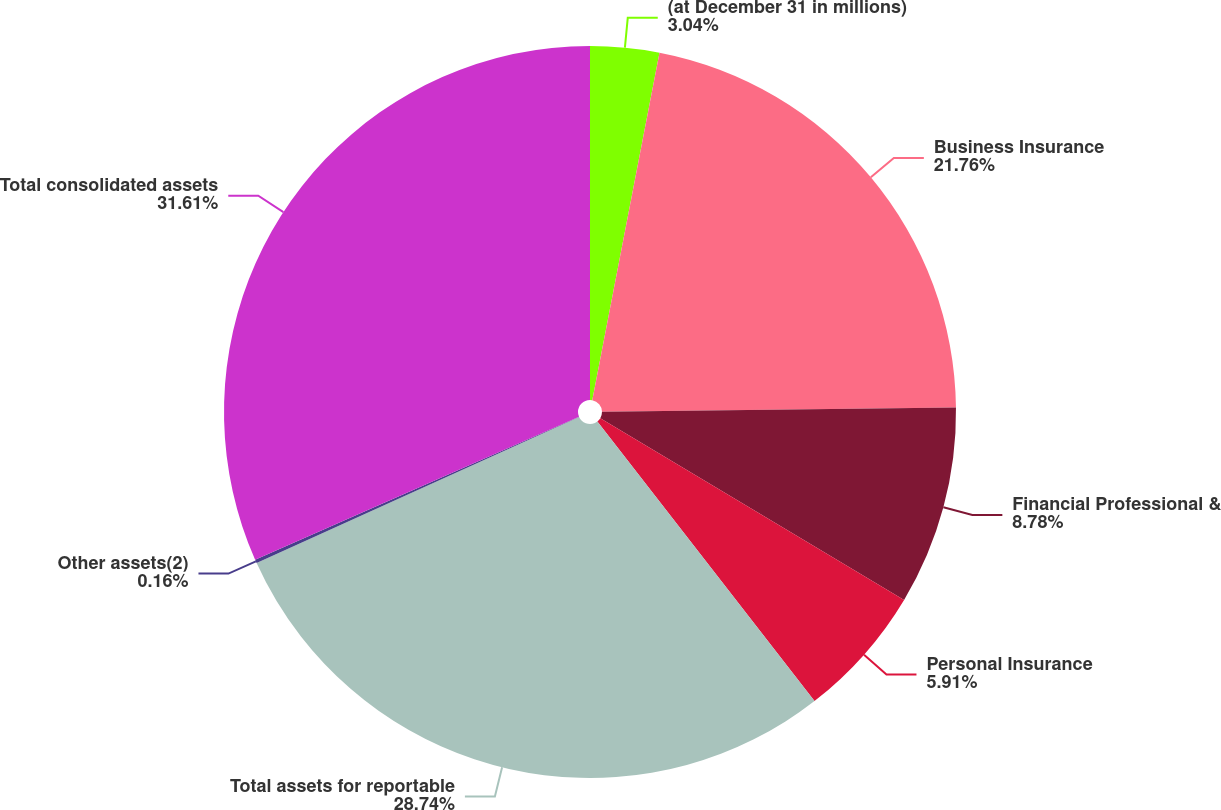Convert chart. <chart><loc_0><loc_0><loc_500><loc_500><pie_chart><fcel>(at December 31 in millions)<fcel>Business Insurance<fcel>Financial Professional &<fcel>Personal Insurance<fcel>Total assets for reportable<fcel>Other assets(2)<fcel>Total consolidated assets<nl><fcel>3.04%<fcel>21.76%<fcel>8.78%<fcel>5.91%<fcel>28.74%<fcel>0.16%<fcel>31.61%<nl></chart> 